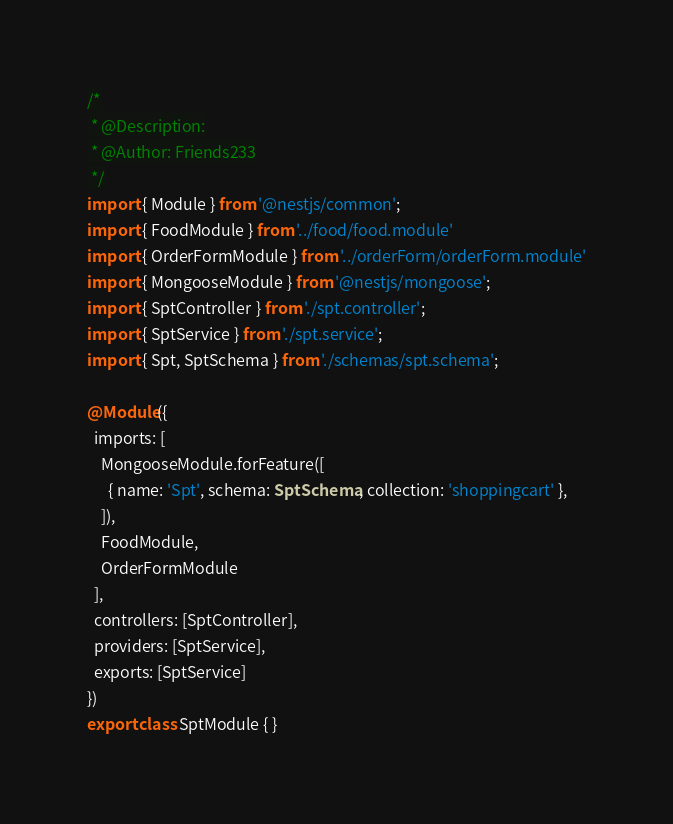Convert code to text. <code><loc_0><loc_0><loc_500><loc_500><_TypeScript_>/*
 * @Description:
 * @Author: Friends233
 */
import { Module } from '@nestjs/common';
import { FoodModule } from '../food/food.module'
import { OrderFormModule } from '../orderForm/orderForm.module'
import { MongooseModule } from '@nestjs/mongoose';
import { SptController } from './spt.controller';
import { SptService } from './spt.service';
import { Spt, SptSchema } from './schemas/spt.schema';

@Module({
  imports: [
    MongooseModule.forFeature([
      { name: 'Spt', schema: SptSchema, collection: 'shoppingcart' },
    ]),
    FoodModule,
    OrderFormModule
  ],
  controllers: [SptController],
  providers: [SptService],
  exports: [SptService]
})
export class SptModule { }
</code> 